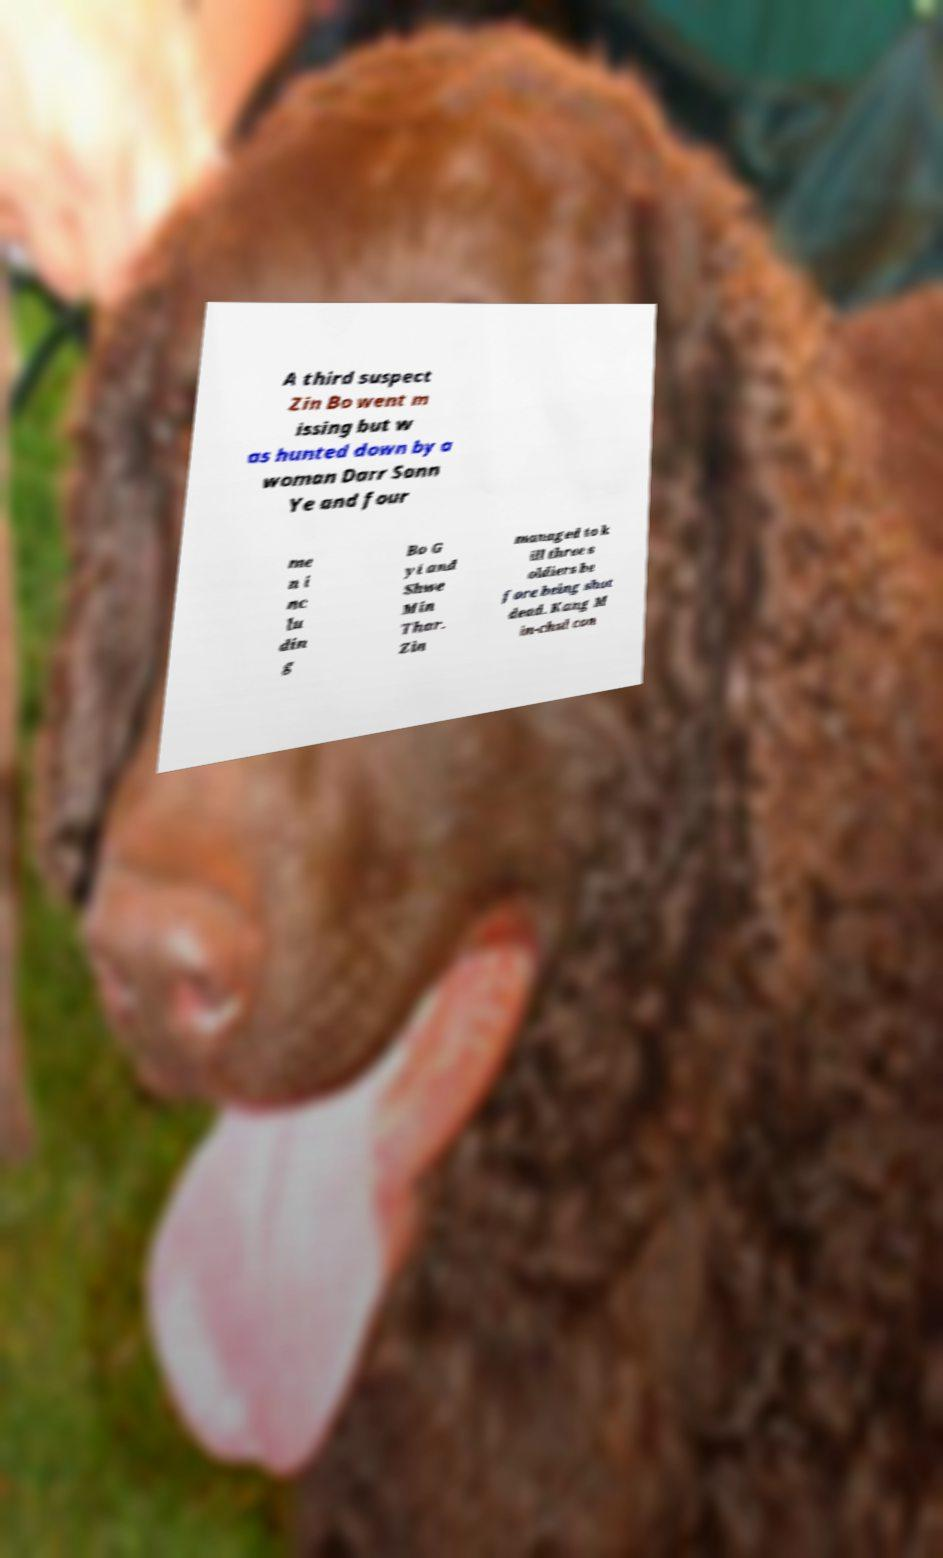For documentation purposes, I need the text within this image transcribed. Could you provide that? A third suspect Zin Bo went m issing but w as hunted down by a woman Darr Sann Ye and four me n i nc lu din g Bo G yi and Shwe Min Thar. Zin managed to k ill three s oldiers be fore being shot dead. Kang M in-chul con 